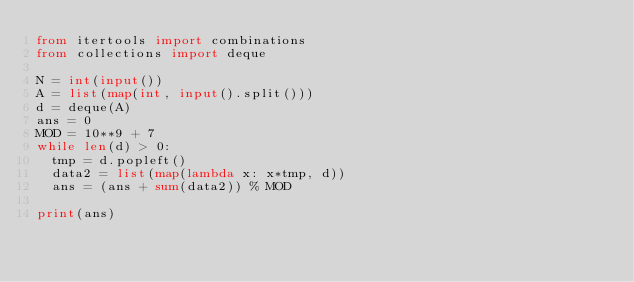<code> <loc_0><loc_0><loc_500><loc_500><_Python_>from itertools import combinations
from collections import deque

N = int(input())
A = list(map(int, input().split()))
d = deque(A)
ans = 0
MOD = 10**9 + 7
while len(d) > 0:
  tmp = d.popleft()
  data2 = list(map(lambda x: x*tmp, d))
  ans = (ans + sum(data2)) % MOD

print(ans)</code> 